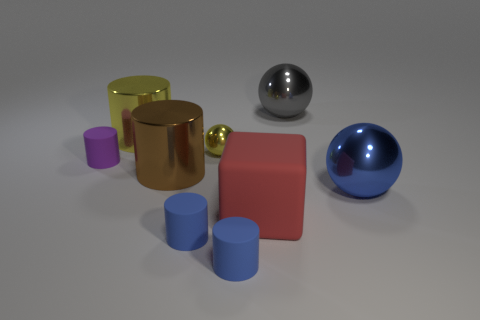What is the red block made of?
Provide a short and direct response. Rubber. There is a purple matte object that is the same shape as the large brown object; what is its size?
Make the answer very short. Small. What number of other objects are the same material as the gray thing?
Ensure brevity in your answer.  4. Are there the same number of big gray spheres to the left of the red cube and tiny cubes?
Make the answer very short. Yes. There is a shiny thing in front of the brown shiny object; is its size the same as the tiny shiny sphere?
Your answer should be compact. No. There is a matte block; how many small matte cylinders are behind it?
Your response must be concise. 1. There is a blue thing that is both to the right of the tiny metal sphere and in front of the blue ball; what is its material?
Keep it short and to the point. Rubber. What number of big things are either yellow metal cylinders or gray metal things?
Provide a succinct answer. 2. How big is the yellow sphere?
Provide a short and direct response. Small. The large gray object is what shape?
Offer a very short reply. Sphere. 